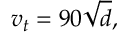<formula> <loc_0><loc_0><loc_500><loc_500>v _ { t } = 9 0 { \sqrt { d } } ,</formula> 